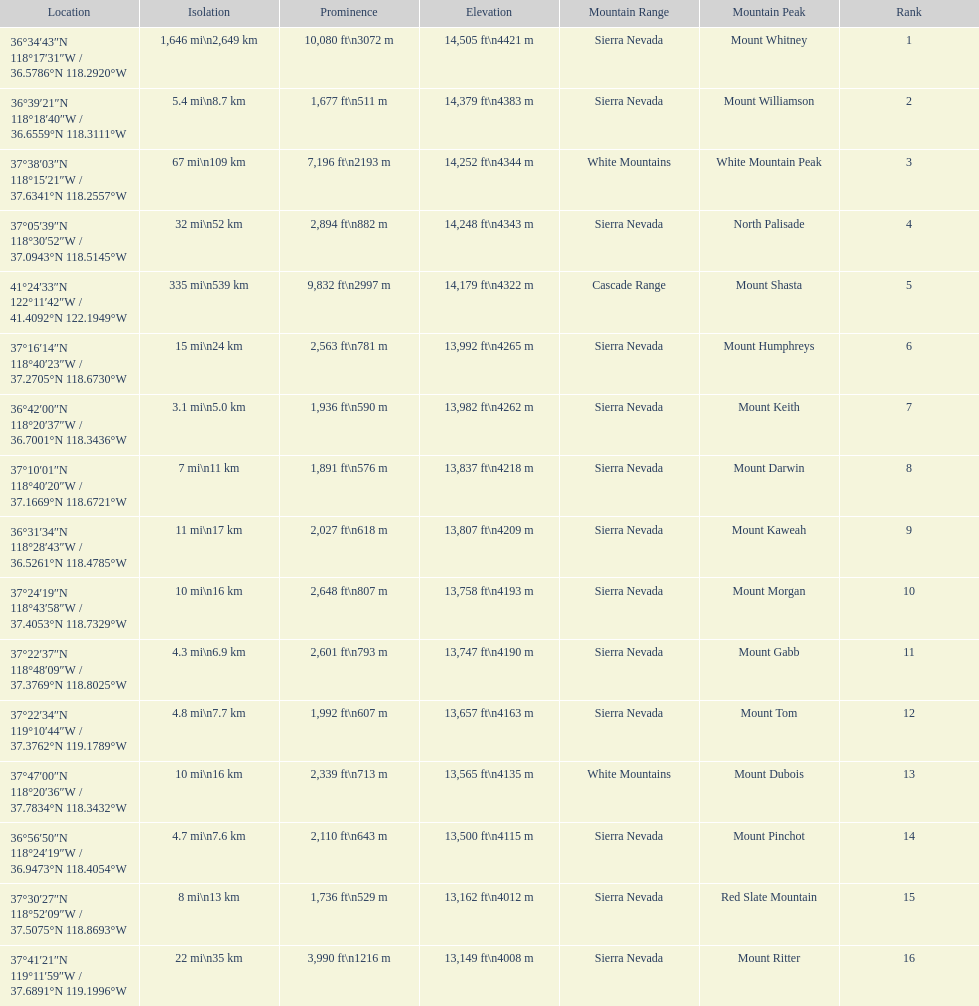Which mountain peak is no higher than 13,149 ft? Mount Ritter. 